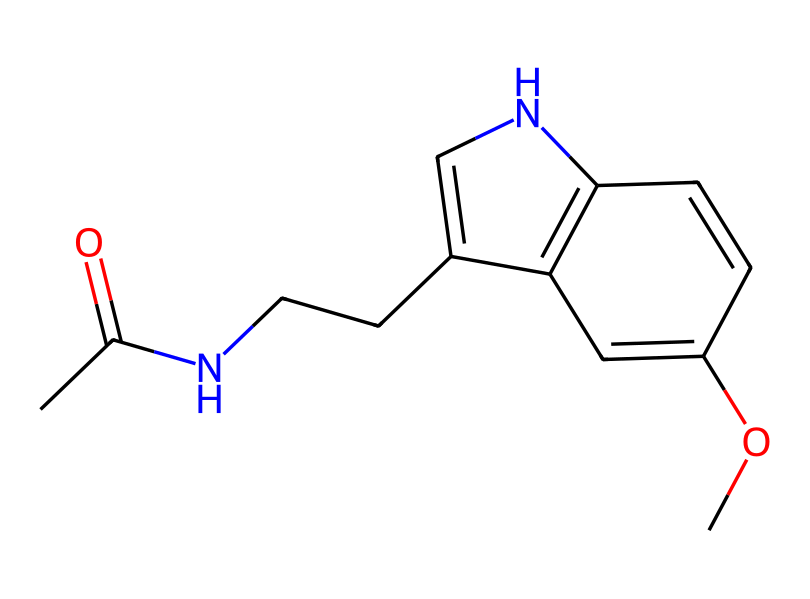What is the molecular formula of melatonin? To determine the molecular formula, we count the number of carbon (C), hydrogen (H), nitrogen (N), and oxygen (O) atoms in the structure. The structure contains 13 carbon atoms, 16 hydrogen atoms, 2 nitrogen atoms, and 1 oxygen atom. Therefore, the molecular formula is C13H16N2O.
Answer: C13H16N2O How many nitrogen atoms are present in melatonin? By analyzing the SMILES representation, we can identify the nitrogen atoms in the structure. There are 2 nitrogen atoms present in the molecular structure.
Answer: 2 What type of functional groups are present in melatonin? In the provided structure, we can see that melatonin contains an amide functional group (from the CC(=O)N segment) and a methoxy group (from the OC segment). Overall, melatonin features both amide and ether functional groups.
Answer: amide, ether What is the significance of the methoxy group in melatonin? The methoxy group (-OCH3) in melatonin can enhance its lipophilicity, thereby affecting its ability to cross the blood-brain barrier and influence sleep regulation. This functional group contributes to the overall biological activity of melatonin.
Answer: biological activity How does the cyclic structure relate to the activity of melatonin? The cyclic structure, specifically the presence of a pyridine ring, contributes to the stability and binding affinity of melatonin to its receptors in the brain. This cyclic nature is crucial for its role in regulating circadian rhythms and sleep patterns.
Answer: binding affinity What type of chemical is melatonin categorized as? Melatonin is categorized as an indoleamine due to its indole structure within the backbone, which is characteristic of tryptophan derivatives. This classification highlights its role in neurotransmission.
Answer: indoleamine 